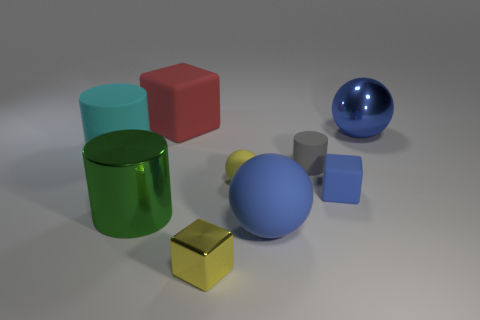Add 1 tiny blue shiny objects. How many objects exist? 10 Subtract all gray cylinders. How many cylinders are left? 2 Subtract all tiny cylinders. Subtract all blue matte balls. How many objects are left? 7 Add 1 big blue matte things. How many big blue matte things are left? 2 Add 4 brown cylinders. How many brown cylinders exist? 4 Subtract all large metal cylinders. How many cylinders are left? 2 Subtract 1 blue blocks. How many objects are left? 8 Subtract all spheres. How many objects are left? 6 Subtract 1 blocks. How many blocks are left? 2 Subtract all brown cubes. Subtract all cyan spheres. How many cubes are left? 3 